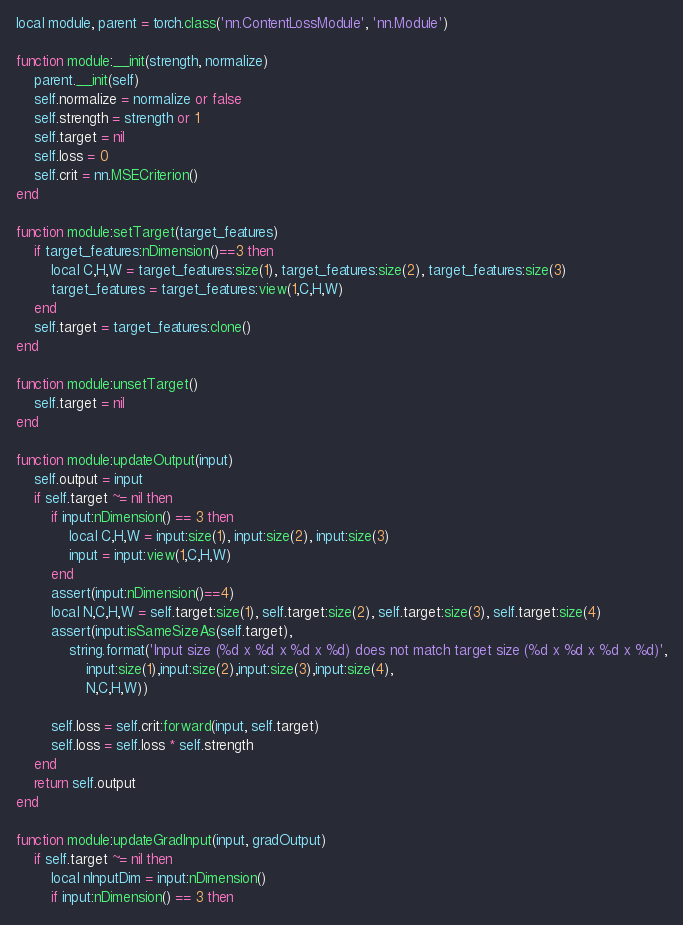Convert code to text. <code><loc_0><loc_0><loc_500><loc_500><_Lua_>local module, parent = torch.class('nn.ContentLossModule', 'nn.Module')

function module:__init(strength, normalize)
    parent.__init(self)
    self.normalize = normalize or false
    self.strength = strength or 1
    self.target = nil
    self.loss = 0
    self.crit = nn.MSECriterion()
end

function module:setTarget(target_features)
    if target_features:nDimension()==3 then
        local C,H,W = target_features:size(1), target_features:size(2), target_features:size(3)
        target_features = target_features:view(1,C,H,W)
    end
    self.target = target_features:clone()
end

function module:unsetTarget()
    self.target = nil
end

function module:updateOutput(input)
    self.output = input
    if self.target ~= nil then
        if input:nDimension() == 3 then
            local C,H,W = input:size(1), input:size(2), input:size(3)
            input = input:view(1,C,H,W)
        end
        assert(input:nDimension()==4)
        local N,C,H,W = self.target:size(1), self.target:size(2), self.target:size(3), self.target:size(4)
        assert(input:isSameSizeAs(self.target),
            string.format('Input size (%d x %d x %d x %d) does not match target size (%d x %d x %d x %d)',
                input:size(1),input:size(2),input:size(3),input:size(4),
                N,C,H,W))

        self.loss = self.crit:forward(input, self.target)
        self.loss = self.loss * self.strength
    end
    return self.output
end

function module:updateGradInput(input, gradOutput)
    if self.target ~= nil then
        local nInputDim = input:nDimension()
        if input:nDimension() == 3 then</code> 